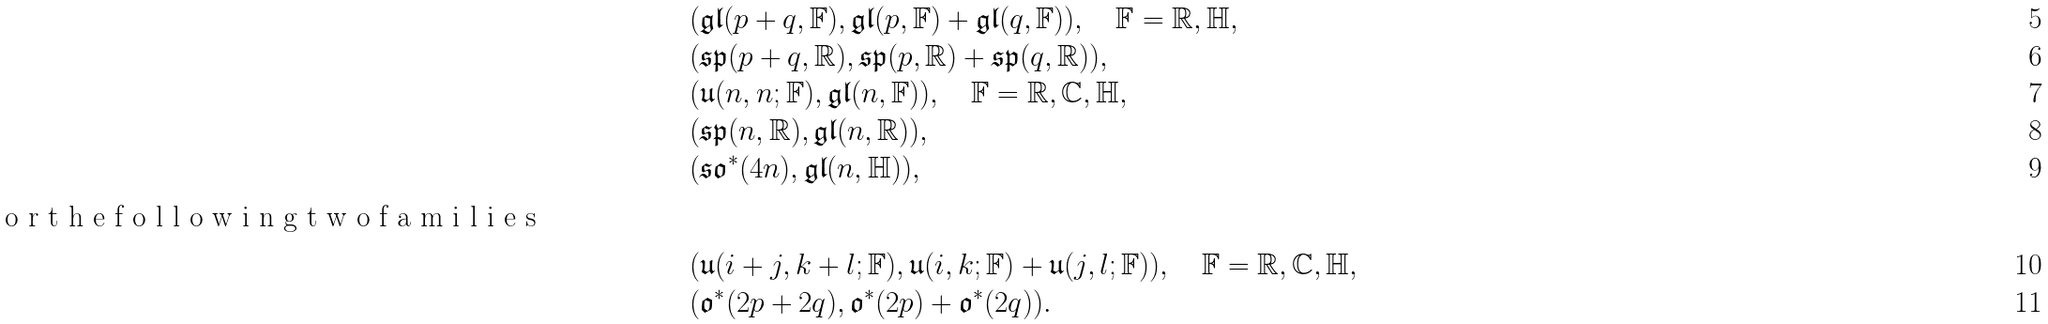Convert formula to latex. <formula><loc_0><loc_0><loc_500><loc_500>& ( { \mathfrak { g l } } ( p + q , { \mathbb { F } } ) , { \mathfrak { g l } } ( p , { \mathbb { F } } ) + { \mathfrak { g l } } ( q , { \mathbb { F } } ) ) , \quad \mathbb { F } = { \mathbb { R } } , { \mathbb { H } } , \\ & ( { \mathfrak { s p } } ( p + q , { \mathbb { R } } ) , { \mathfrak { s p } } ( p , { \mathbb { R } } ) + { \mathfrak { s p } } ( q , { \mathbb { R } } ) ) , \\ & ( { \mathfrak { u } } ( n , n ; { \mathbb { F } } ) , { \mathfrak { g l } } ( n , { \mathbb { F } } ) ) , \quad \mathbb { F } = { \mathbb { R } } , { \mathbb { C } } , { \mathbb { H } } , \\ & ( { \mathfrak { s p } } ( n , { \mathbb { R } } ) , { \mathfrak { g l } } ( n , { \mathbb { R } } ) ) , \\ & ( { \mathfrak { s o } } ^ { \ast } ( 4 n ) , { \mathfrak { g l } } ( n , { \mathbb { H } } ) ) , \\ \intertext { o r t h e f o l l o w i n g t w o f a m i l i e s } & ( { \mathfrak { u } } ( i + j , k + l ; { \mathbb { F } } ) , { \mathfrak { u } } ( i , k ; { \mathbb { F } } ) + { \mathfrak { u } } ( j , l ; { \mathbb { F } } ) ) , \quad \mathbb { F } = { \mathbb { R } } , { \mathbb { C } } , { \mathbb { H } } , \\ & ( { \mathfrak { o } } ^ { \ast } ( 2 p + 2 q ) , { \mathfrak { o } } ^ { \ast } ( 2 p ) + { \mathfrak { o } } ^ { \ast } ( 2 q ) ) .</formula> 